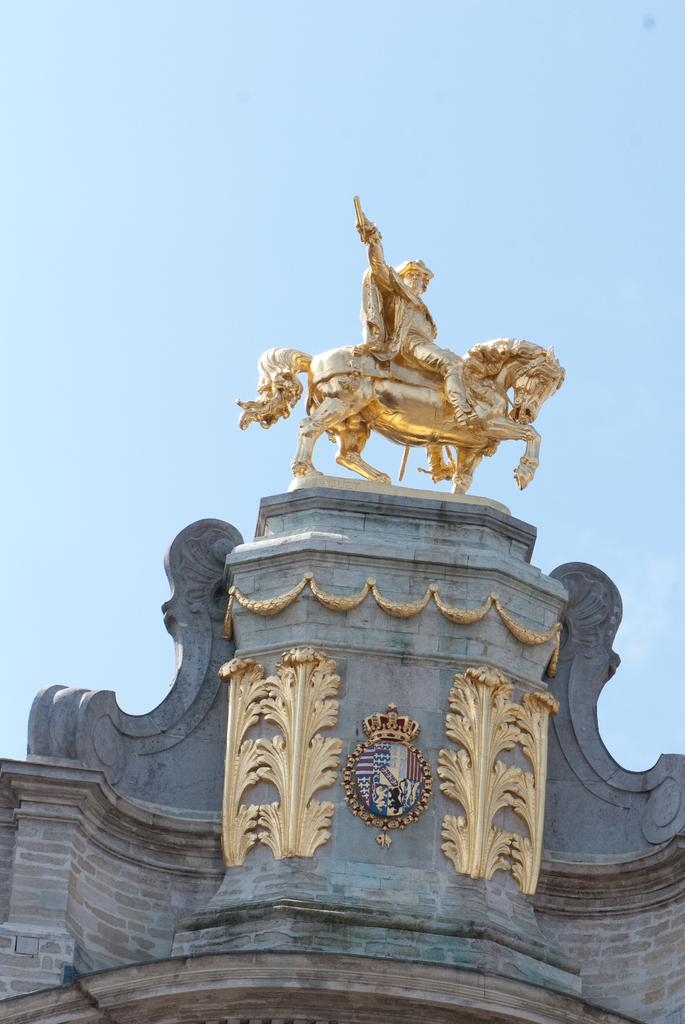What is one of the main features in the image? There is a wall in the image. What can be seen on the wall? There is a golden color sculpture in the image. What is visible in the background of the image? The sky is visible in the background of the image. How much profit does the sculpture generate in the image? There is no information about the sculpture generating profit in the image, as it is a static representation of an artwork. 